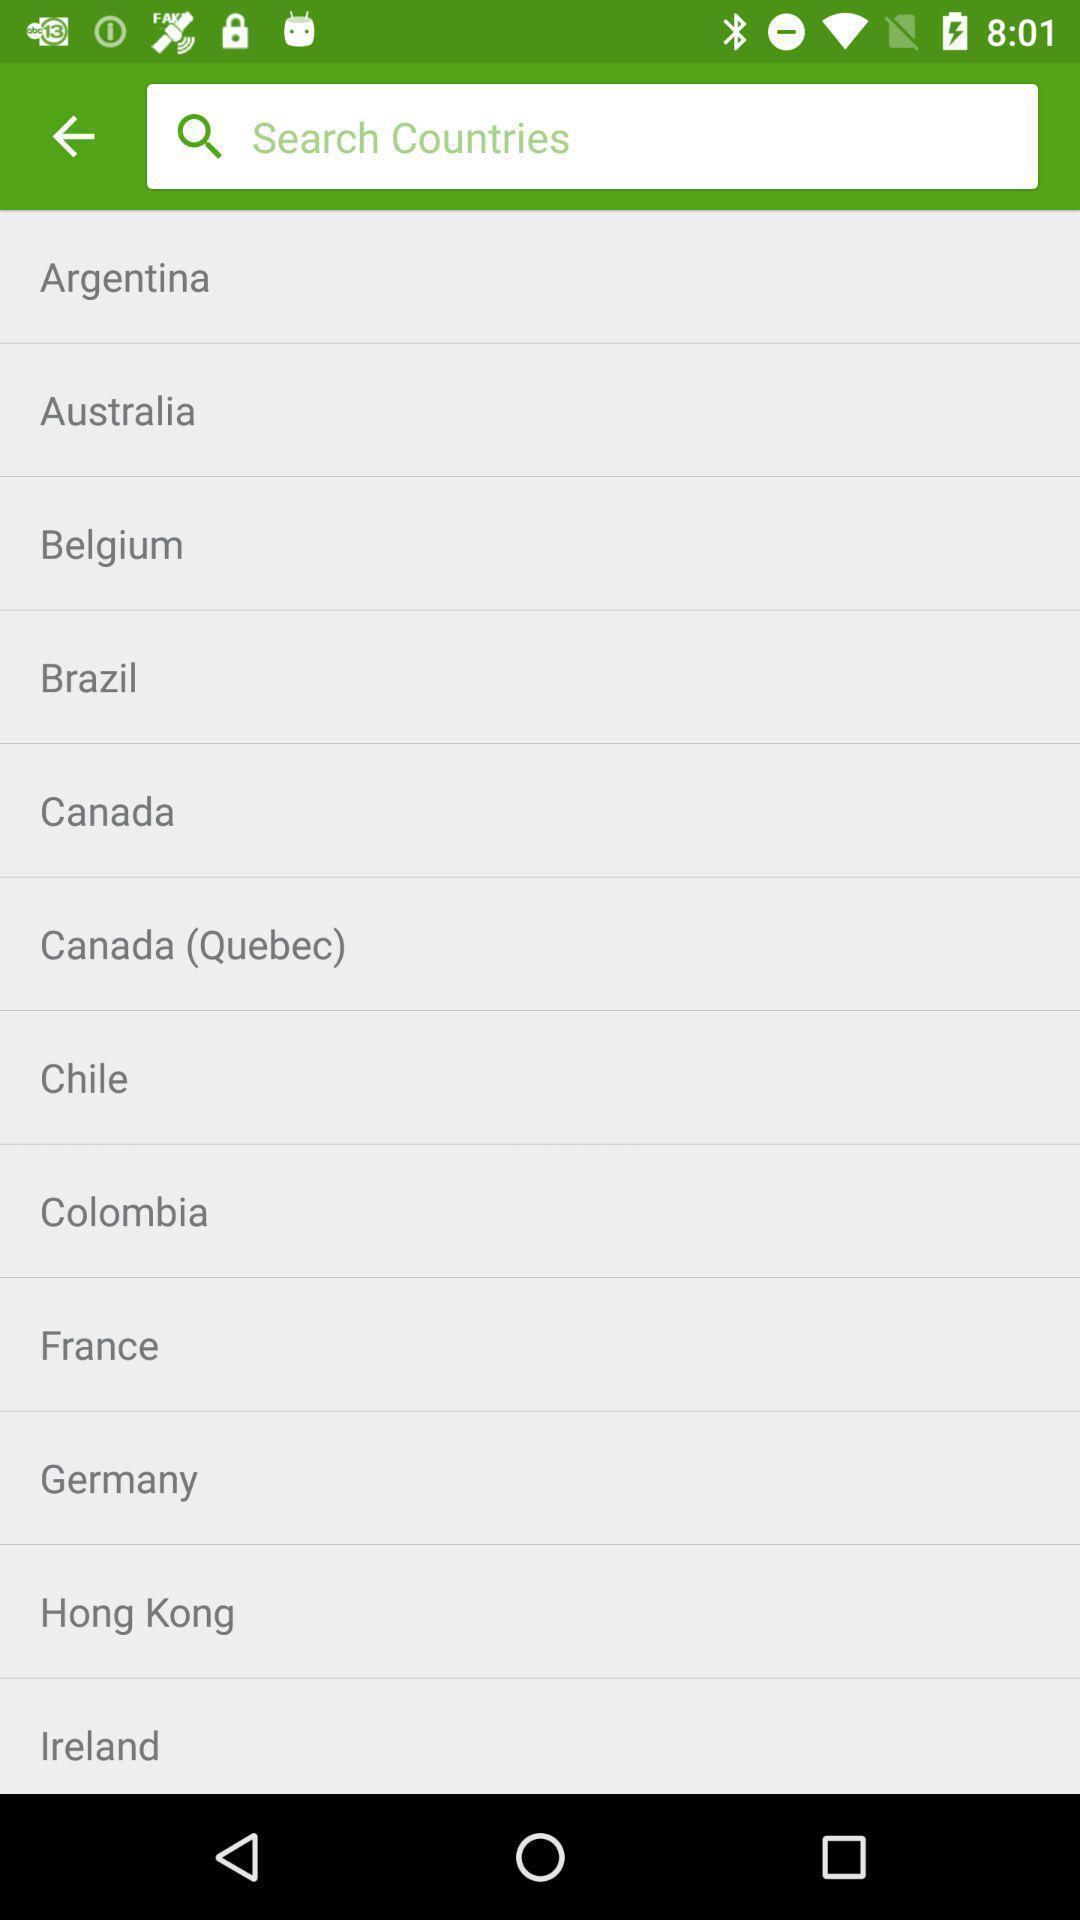Explain the elements present in this screenshot. Search page for searching countries for an app. 